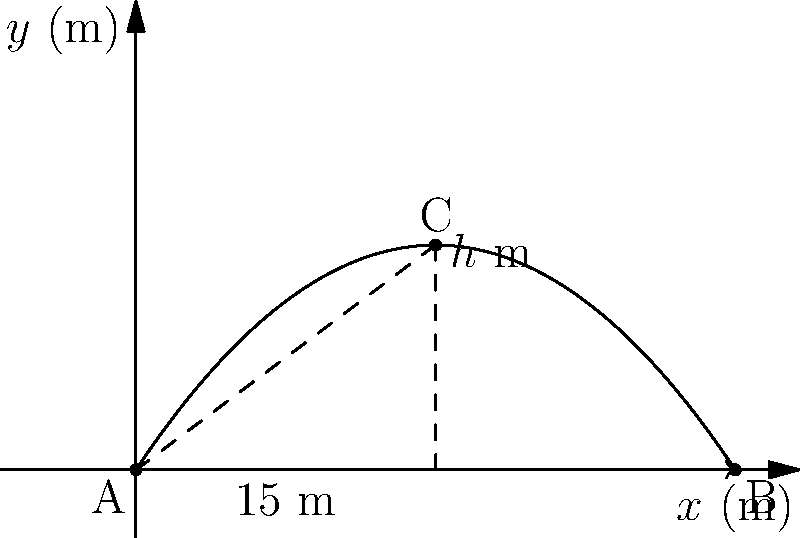A golfer hits a ball from point A, and it follows a parabolic trajectory as shown in the diagram. The ball lands at point B, 30 meters away from A. The highest point of the trajectory, C, occurs when the ball is 15 meters horizontally from A. Given that the trajectory of the golf ball can be modeled by the equation $y = -ax^2 + bx$, where $x$ and $y$ are in meters, determine:

a) The value of $a$
b) The value of $b$
c) The maximum height $h$ reached by the golf ball Let's approach this step-by-step:

1) The general equation of the trajectory is $y = -ax^2 + bx$

2) We know three points on this trajectory:
   A(0,0), B(30,0), and C(15,h)

3) Let's use point B to find a relation between $a$ and $b$:
   $0 = -a(30)^2 + b(30)$
   $0 = -900a + 30b$
   $b = 30a$ ... (Equation 1)

4) The maximum point C occurs at $x = 15$. At the maximum point, the derivative of $y$ with respect to $x$ is zero:
   $\frac{dy}{dx} = -2ax + b = 0$
   $-2a(15) + b = 0$
   $b = 30a$ ... (Equation 2)

5) Equations 1 and 2 are identical, confirming our work so far.

6) Now, let's use point C(15,h) in the original equation:
   $h = -a(15)^2 + b(15)$
   $h = -225a + 15b$
   
   Substituting $b = 30a$ from Equation 1:
   $h = -225a + 15(30a)$
   $h = -225a + 450a$
   $h = 225a$

7) To find $a$, we can use the fact that the ball lands at B(30,0):
   $0 = -a(30)^2 + 30a(30)$
   $0 = -900a + 900a$
   
   This is true for any $a$, so we need to use the information about the maximum point.

8) The x-coordinate of the maximum point is the average of the x-coordinates of A and B:
   $15 = \frac{0 + 30}{2}$
   
   This means $a = \frac{b}{60}$ (from the general formula for the x-coordinate of the vertex)

9) Substituting this into Equation 1:
   $b = 30(\frac{b}{60}) = \frac{b}{2}$
   
   This is true when $b = 3$

10) If $b = 3$, then $a = \frac{3}{60} = 0.05$

11) The maximum height $h$ can now be calculated:
    $h = 225a = 225(0.05) = 11.25$ meters
Answer: a) $a = 0.05$
b) $b = 3$
c) $h = 11.25$ meters 